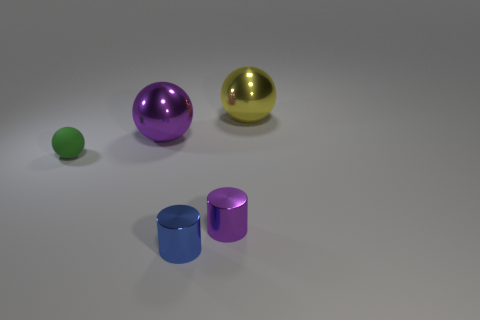What is the shape of the small rubber thing?
Provide a succinct answer. Sphere. What number of purple things are either tiny rubber things or big things?
Offer a terse response. 1. What is the size of the yellow ball that is made of the same material as the tiny purple cylinder?
Your response must be concise. Large. Does the purple object that is in front of the small green rubber ball have the same material as the ball in front of the purple sphere?
Your answer should be very brief. No. How many cubes are either matte things or large metal things?
Your response must be concise. 0. What number of small rubber spheres are in front of the tiny cylinder behind the small shiny cylinder that is in front of the purple cylinder?
Your response must be concise. 0. What material is the big yellow thing that is the same shape as the small matte thing?
Your answer should be compact. Metal. Is there any other thing that is the same material as the green thing?
Offer a very short reply. No. What is the color of the big metallic object to the left of the big yellow shiny sphere?
Make the answer very short. Purple. Are the tiny blue object and the purple thing in front of the green matte sphere made of the same material?
Your answer should be compact. Yes. 